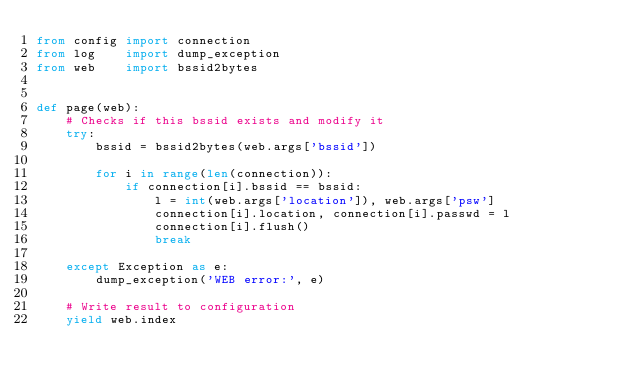Convert code to text. <code><loc_0><loc_0><loc_500><loc_500><_Python_>from config import connection
from log    import dump_exception
from web    import bssid2bytes


def page(web):
    # Checks if this bssid exists and modify it
    try:
        bssid = bssid2bytes(web.args['bssid'])
        
        for i in range(len(connection)):
            if connection[i].bssid == bssid:
                l = int(web.args['location']), web.args['psw']
                connection[i].location, connection[i].passwd = l
                connection[i].flush()
                break
    
    except Exception as e:
        dump_exception('WEB error:', e)
    
    # Write result to configuration
    yield web.index
</code> 